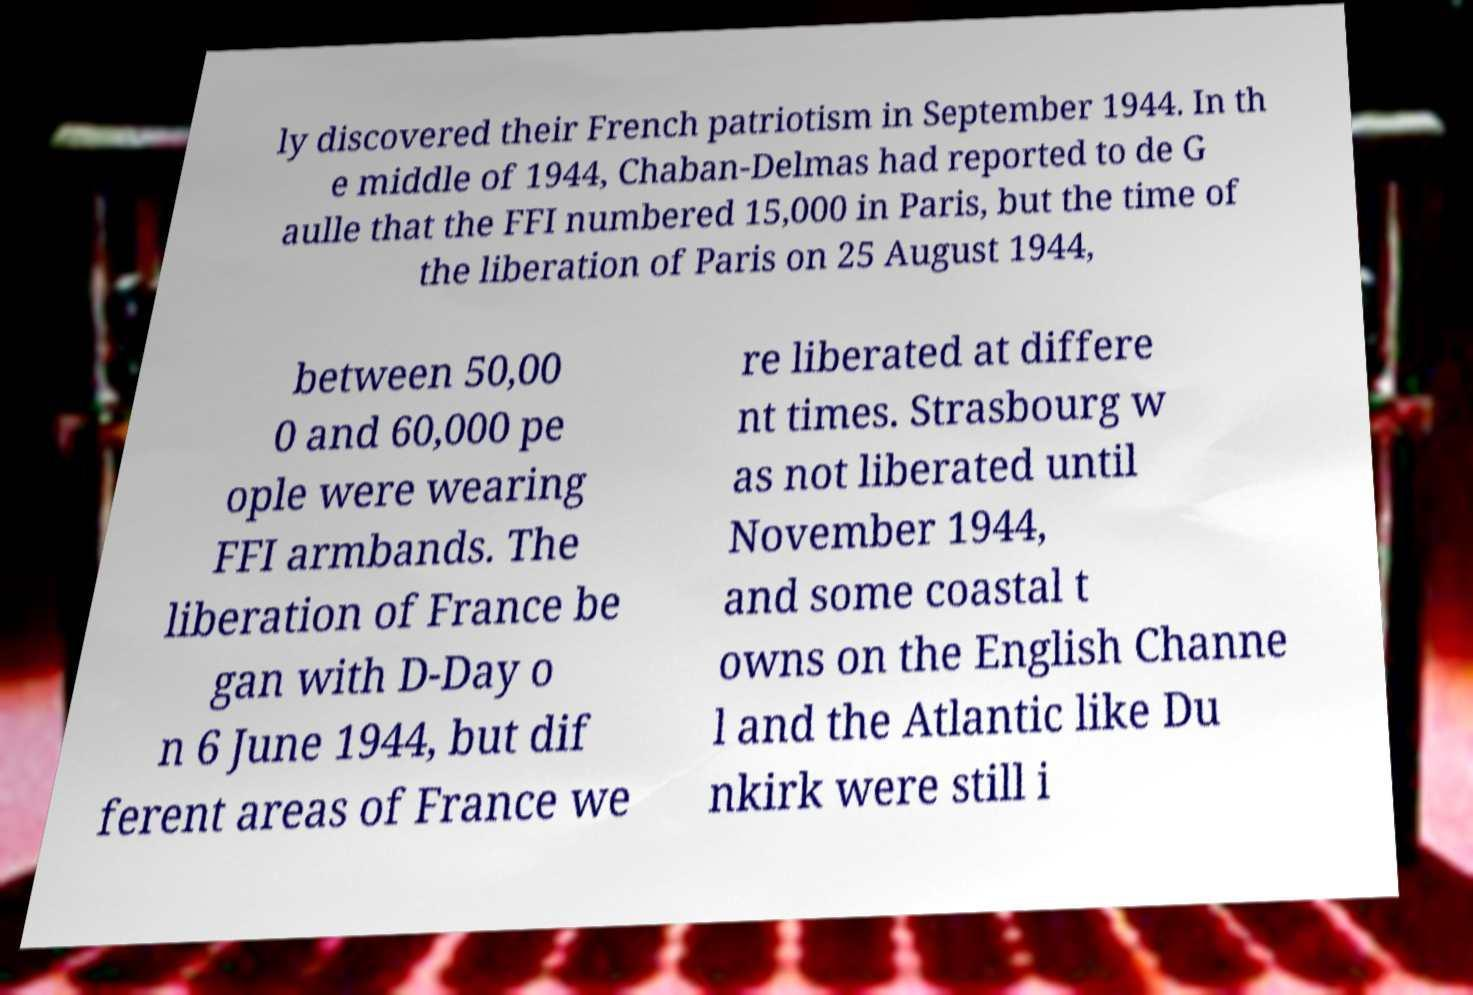Can you read and provide the text displayed in the image?This photo seems to have some interesting text. Can you extract and type it out for me? ly discovered their French patriotism in September 1944. In th e middle of 1944, Chaban-Delmas had reported to de G aulle that the FFI numbered 15,000 in Paris, but the time of the liberation of Paris on 25 August 1944, between 50,00 0 and 60,000 pe ople were wearing FFI armbands. The liberation of France be gan with D-Day o n 6 June 1944, but dif ferent areas of France we re liberated at differe nt times. Strasbourg w as not liberated until November 1944, and some coastal t owns on the English Channe l and the Atlantic like Du nkirk were still i 